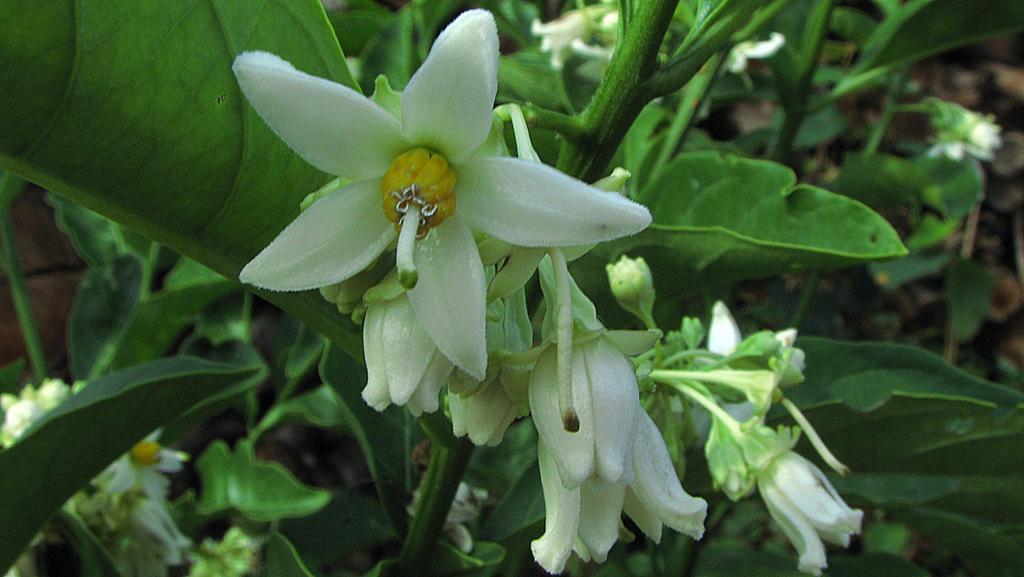How would you summarize this image in a sentence or two? In the image there are white flowers to the plants. 